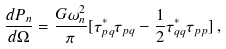<formula> <loc_0><loc_0><loc_500><loc_500>\frac { d P _ { n } } { d \Omega } = \frac { G \omega _ { n } ^ { 2 } } { \pi } [ { \tau } ^ { * } _ { p q } { \tau } _ { p q } - \frac { 1 } { 2 } { \tau } ^ { * } _ { q q } { \tau } _ { p p } ] \, ,</formula> 